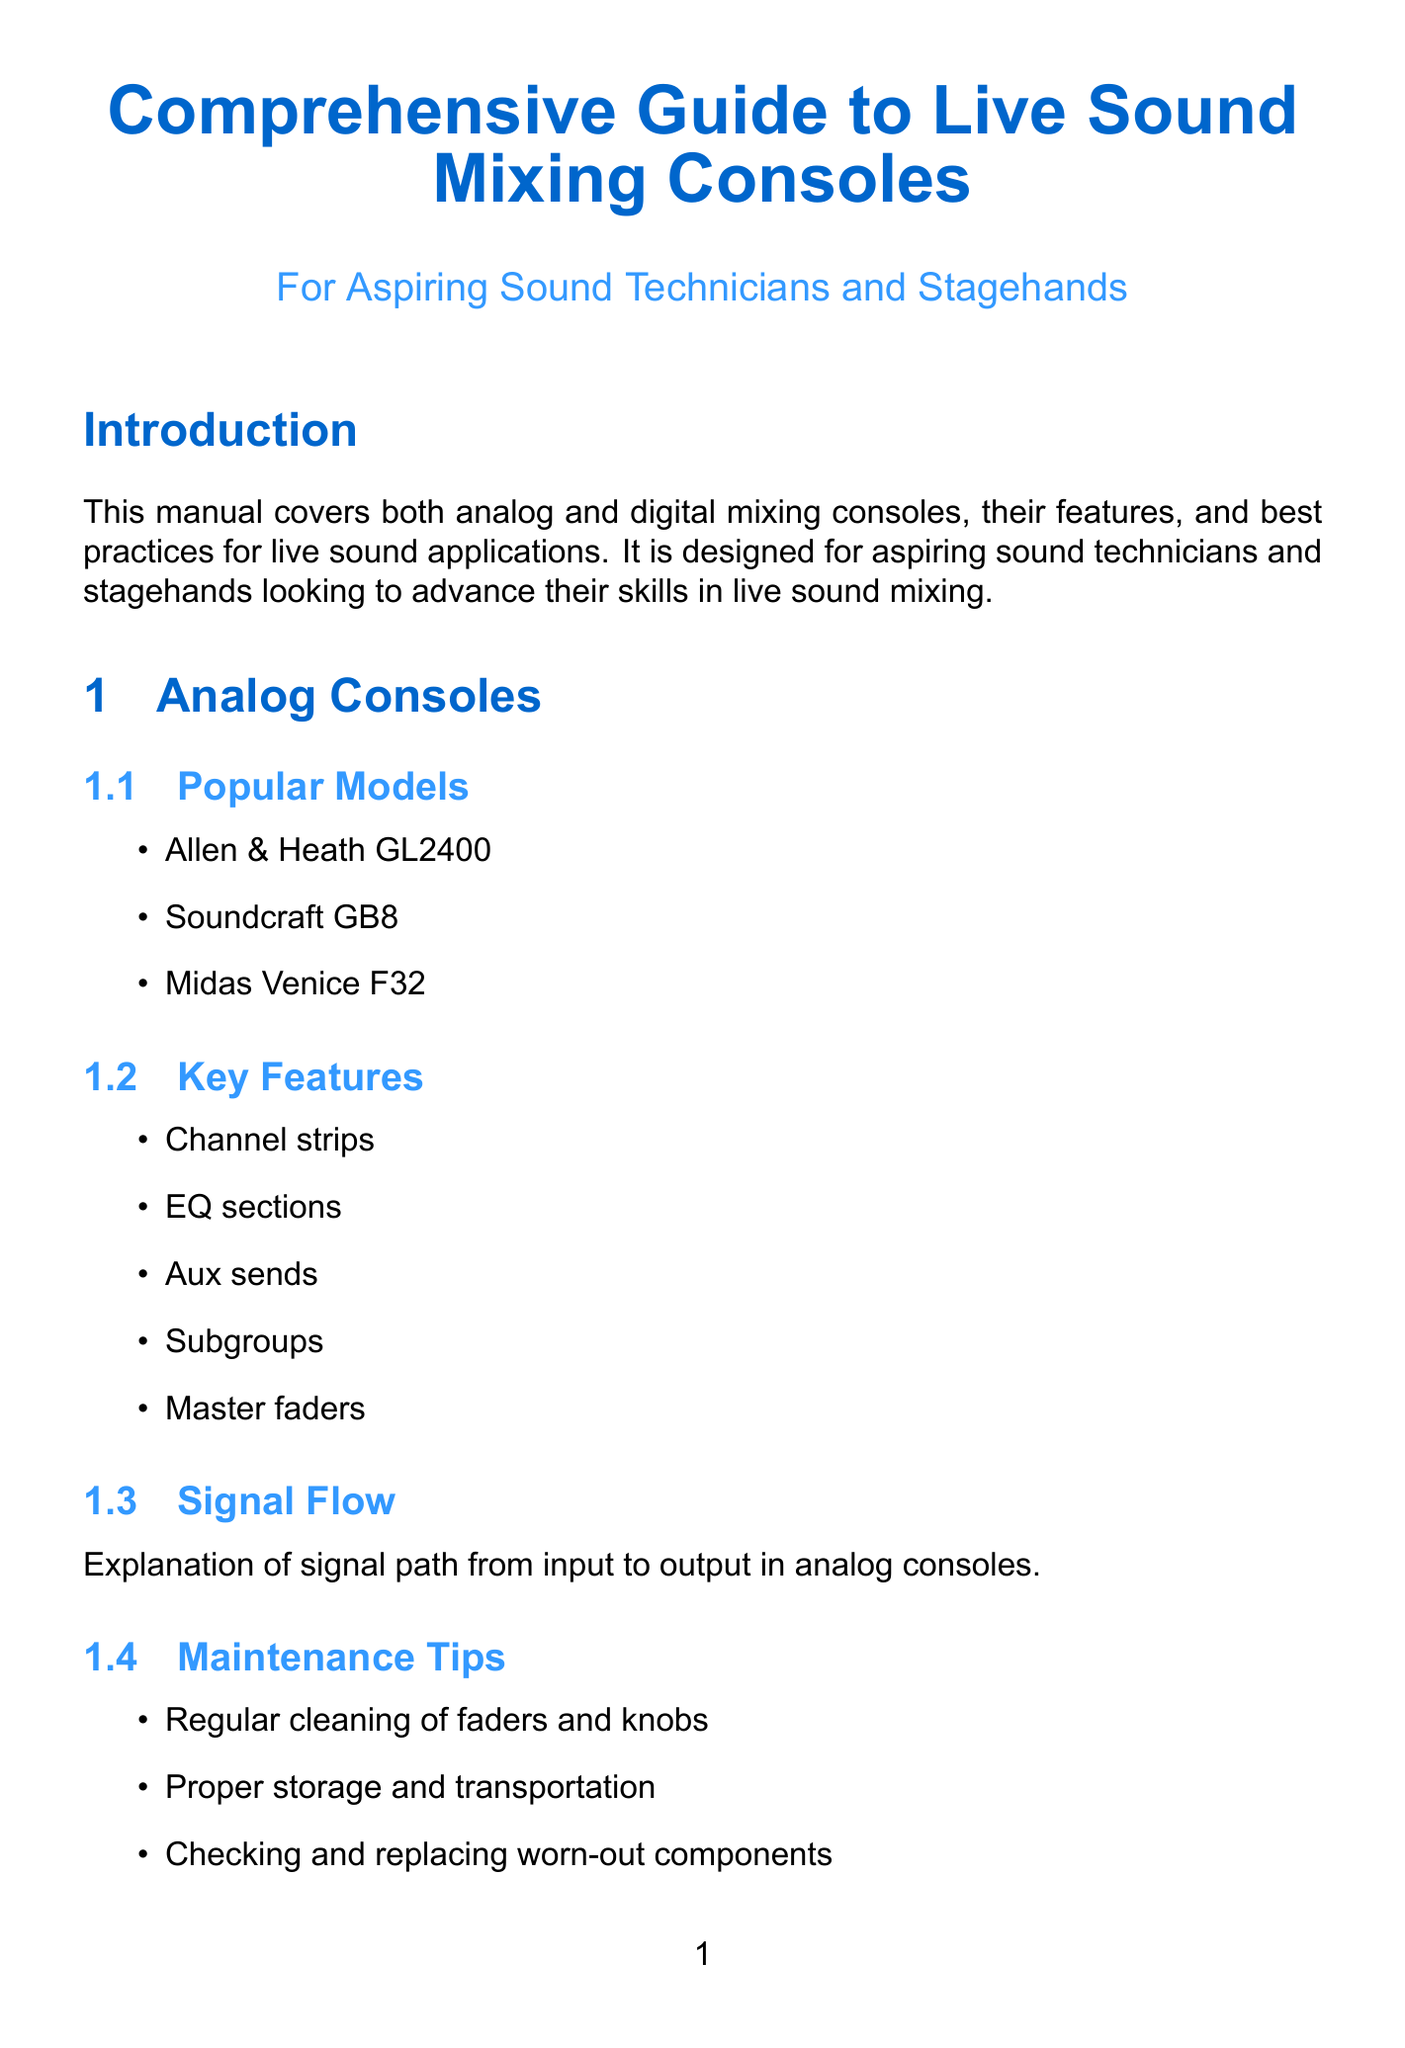What is the title of the manual? The title is specified in the introduction section of the document.
Answer: Comprehensive Guide to Live Sound Mixing Consoles Which analog console features channel strips? Channel strips are listed as a key feature under the analog consoles section.
Answer: Allen & Heath GL2400, Soundcraft GB8, Midas Venice F32 What are the key advantages of digital consoles? Advantages are problem-specific benefits that enhance the performance and usability of digital consoles.
Answer: Compact form factor, Extensive routing options, Built-in effects processors, Scene recall for quick setup Name one type of EQ mentioned in the document. The document lists various types of equalization methods under the equalization section.
Answer: Parametric EQ What is a common application of dynamics processing for drums? The application of gates on drums is an example of dynamics processing discussed in the document.
Answer: Application on drums Which effect types are listed under modulation? The modulation section specifies different effects that can be applied for sound enhancement.
Answer: Chorus, Flanger, Phaser What is one preventive measure mentioned for troubleshooting? Preventive measures are best practices designed to help avoid common issues encountered in live sound.
Answer: Best practices to avoid common problems during live events How many certifications are listed for advancing your career? The certifications are key qualifications referenced in the advancing your career section of the document.
Answer: Four 